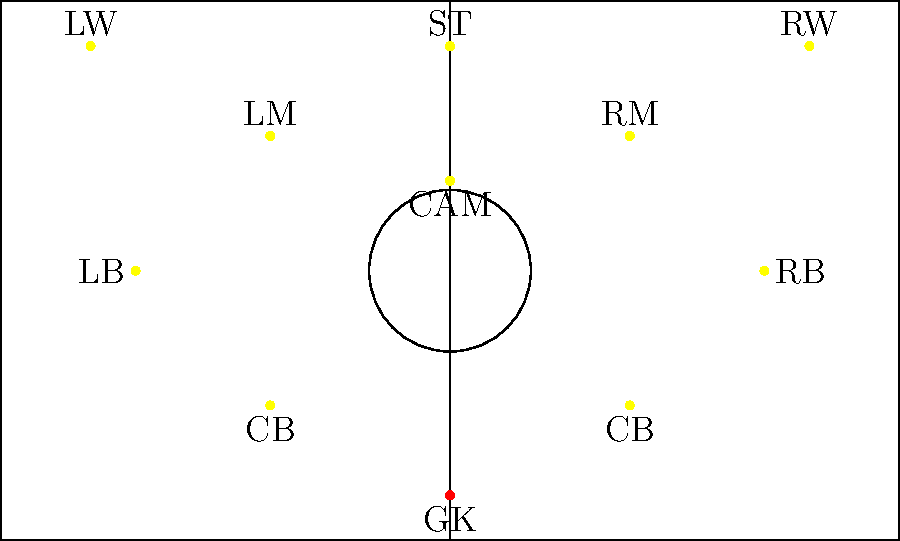Based on the formation shown in the diagram, which tactical setup is the Canaries using for this match? To determine the tactical setup, we need to analyze the positions of the players on the field:

1. There is 1 goalkeeper (GK) at the back.
2. The defensive line consists of 4 players: 2 center-backs (CB) and 2 full-backs (LB and RB).
3. The midfield has 3 players: 2 wide midfielders (LM and RM) and 1 central attacking midfielder (CAM).
4. The forward line has 3 players: 2 wingers (LW and RW) and 1 striker (ST).

Counting the players in each line from back to front, we have:

1-4-3-3

This formation is known as a 4-3-3 formation, with one of the midfielders playing in a more advanced role as a CAM (Central Attacking Midfielder).
Answer: 4-3-3 